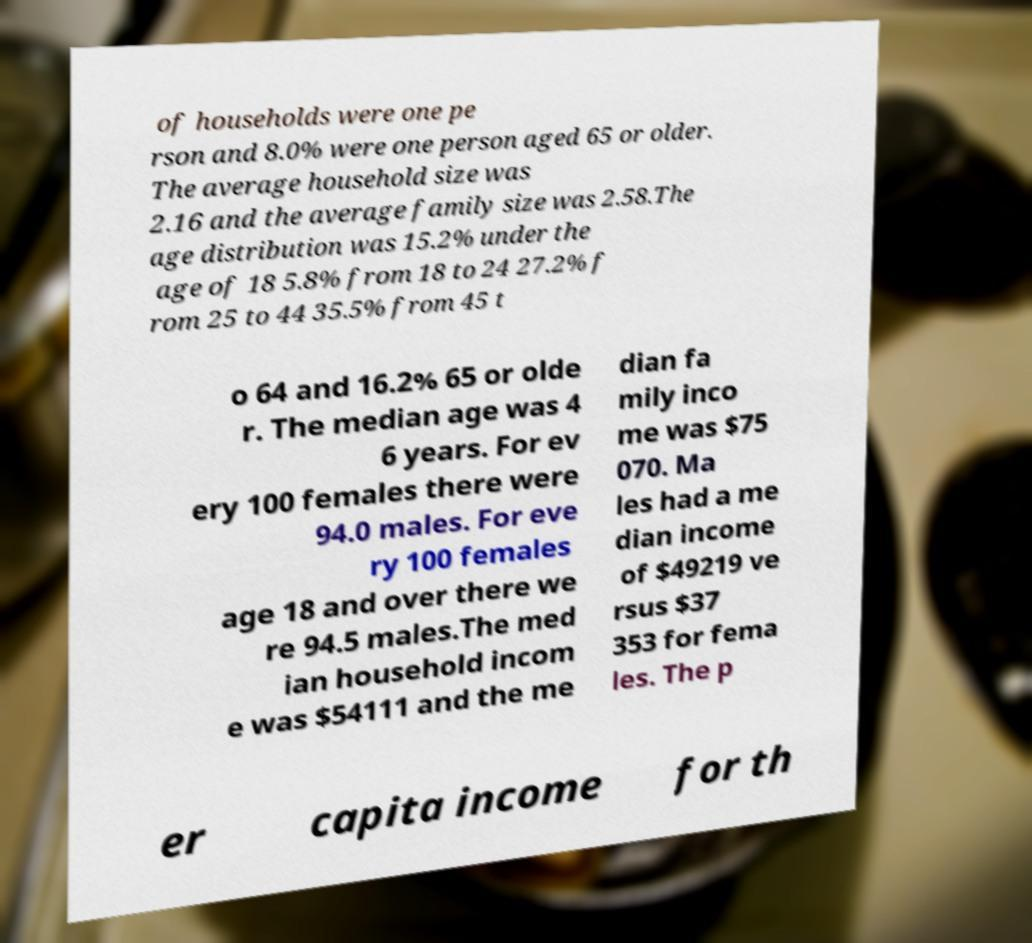Could you assist in decoding the text presented in this image and type it out clearly? of households were one pe rson and 8.0% were one person aged 65 or older. The average household size was 2.16 and the average family size was 2.58.The age distribution was 15.2% under the age of 18 5.8% from 18 to 24 27.2% f rom 25 to 44 35.5% from 45 t o 64 and 16.2% 65 or olde r. The median age was 4 6 years. For ev ery 100 females there were 94.0 males. For eve ry 100 females age 18 and over there we re 94.5 males.The med ian household incom e was $54111 and the me dian fa mily inco me was $75 070. Ma les had a me dian income of $49219 ve rsus $37 353 for fema les. The p er capita income for th 